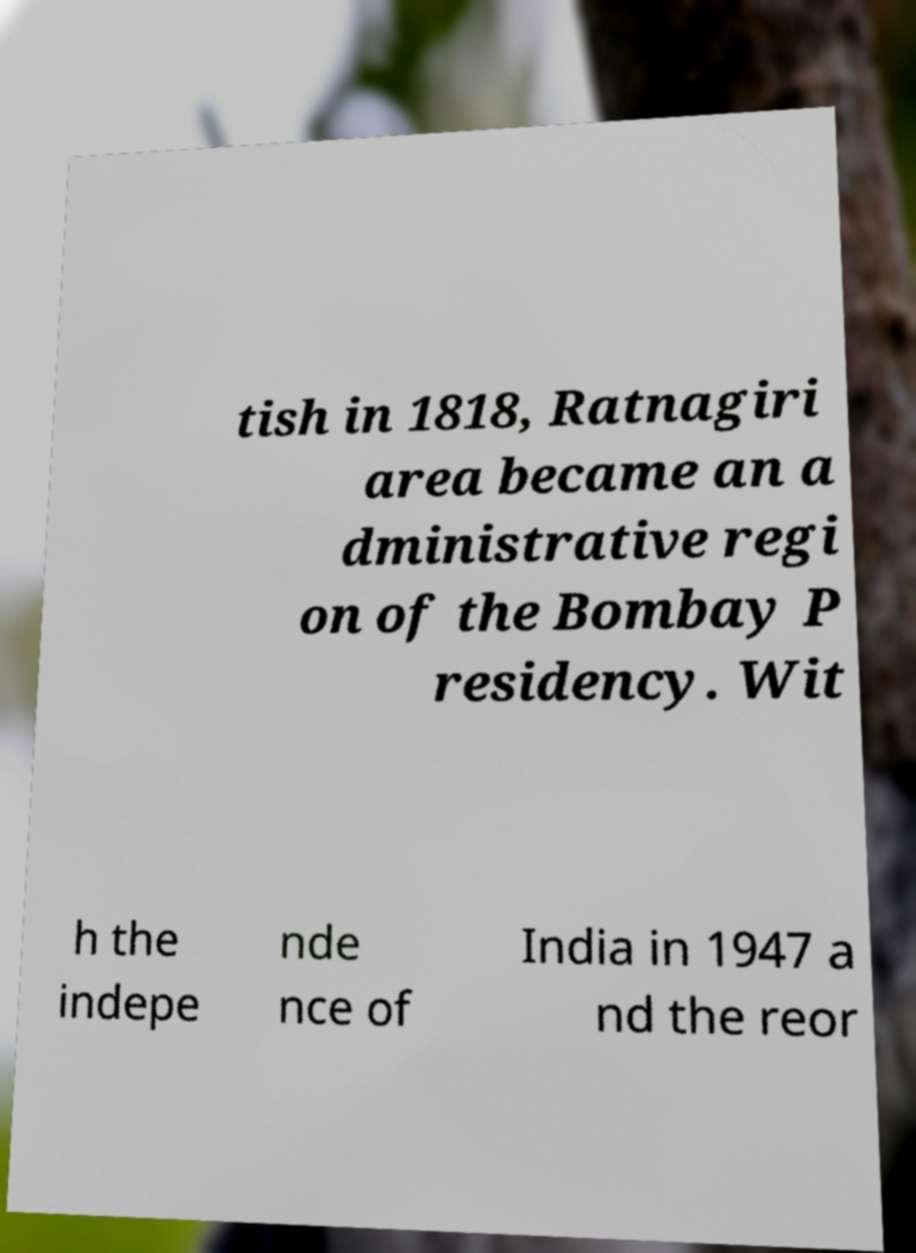Please identify and transcribe the text found in this image. tish in 1818, Ratnagiri area became an a dministrative regi on of the Bombay P residency. Wit h the indepe nde nce of India in 1947 a nd the reor 